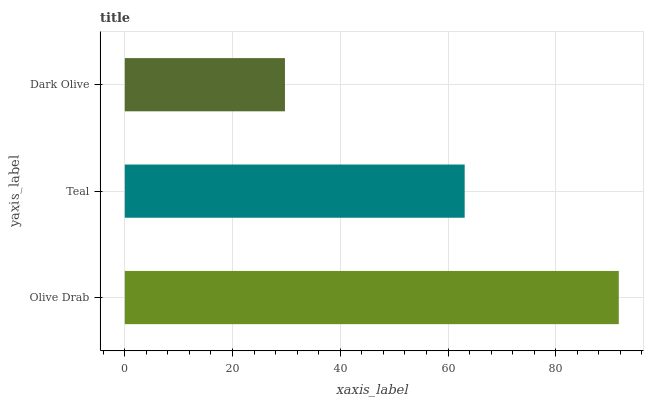Is Dark Olive the minimum?
Answer yes or no. Yes. Is Olive Drab the maximum?
Answer yes or no. Yes. Is Teal the minimum?
Answer yes or no. No. Is Teal the maximum?
Answer yes or no. No. Is Olive Drab greater than Teal?
Answer yes or no. Yes. Is Teal less than Olive Drab?
Answer yes or no. Yes. Is Teal greater than Olive Drab?
Answer yes or no. No. Is Olive Drab less than Teal?
Answer yes or no. No. Is Teal the high median?
Answer yes or no. Yes. Is Teal the low median?
Answer yes or no. Yes. Is Olive Drab the high median?
Answer yes or no. No. Is Dark Olive the low median?
Answer yes or no. No. 